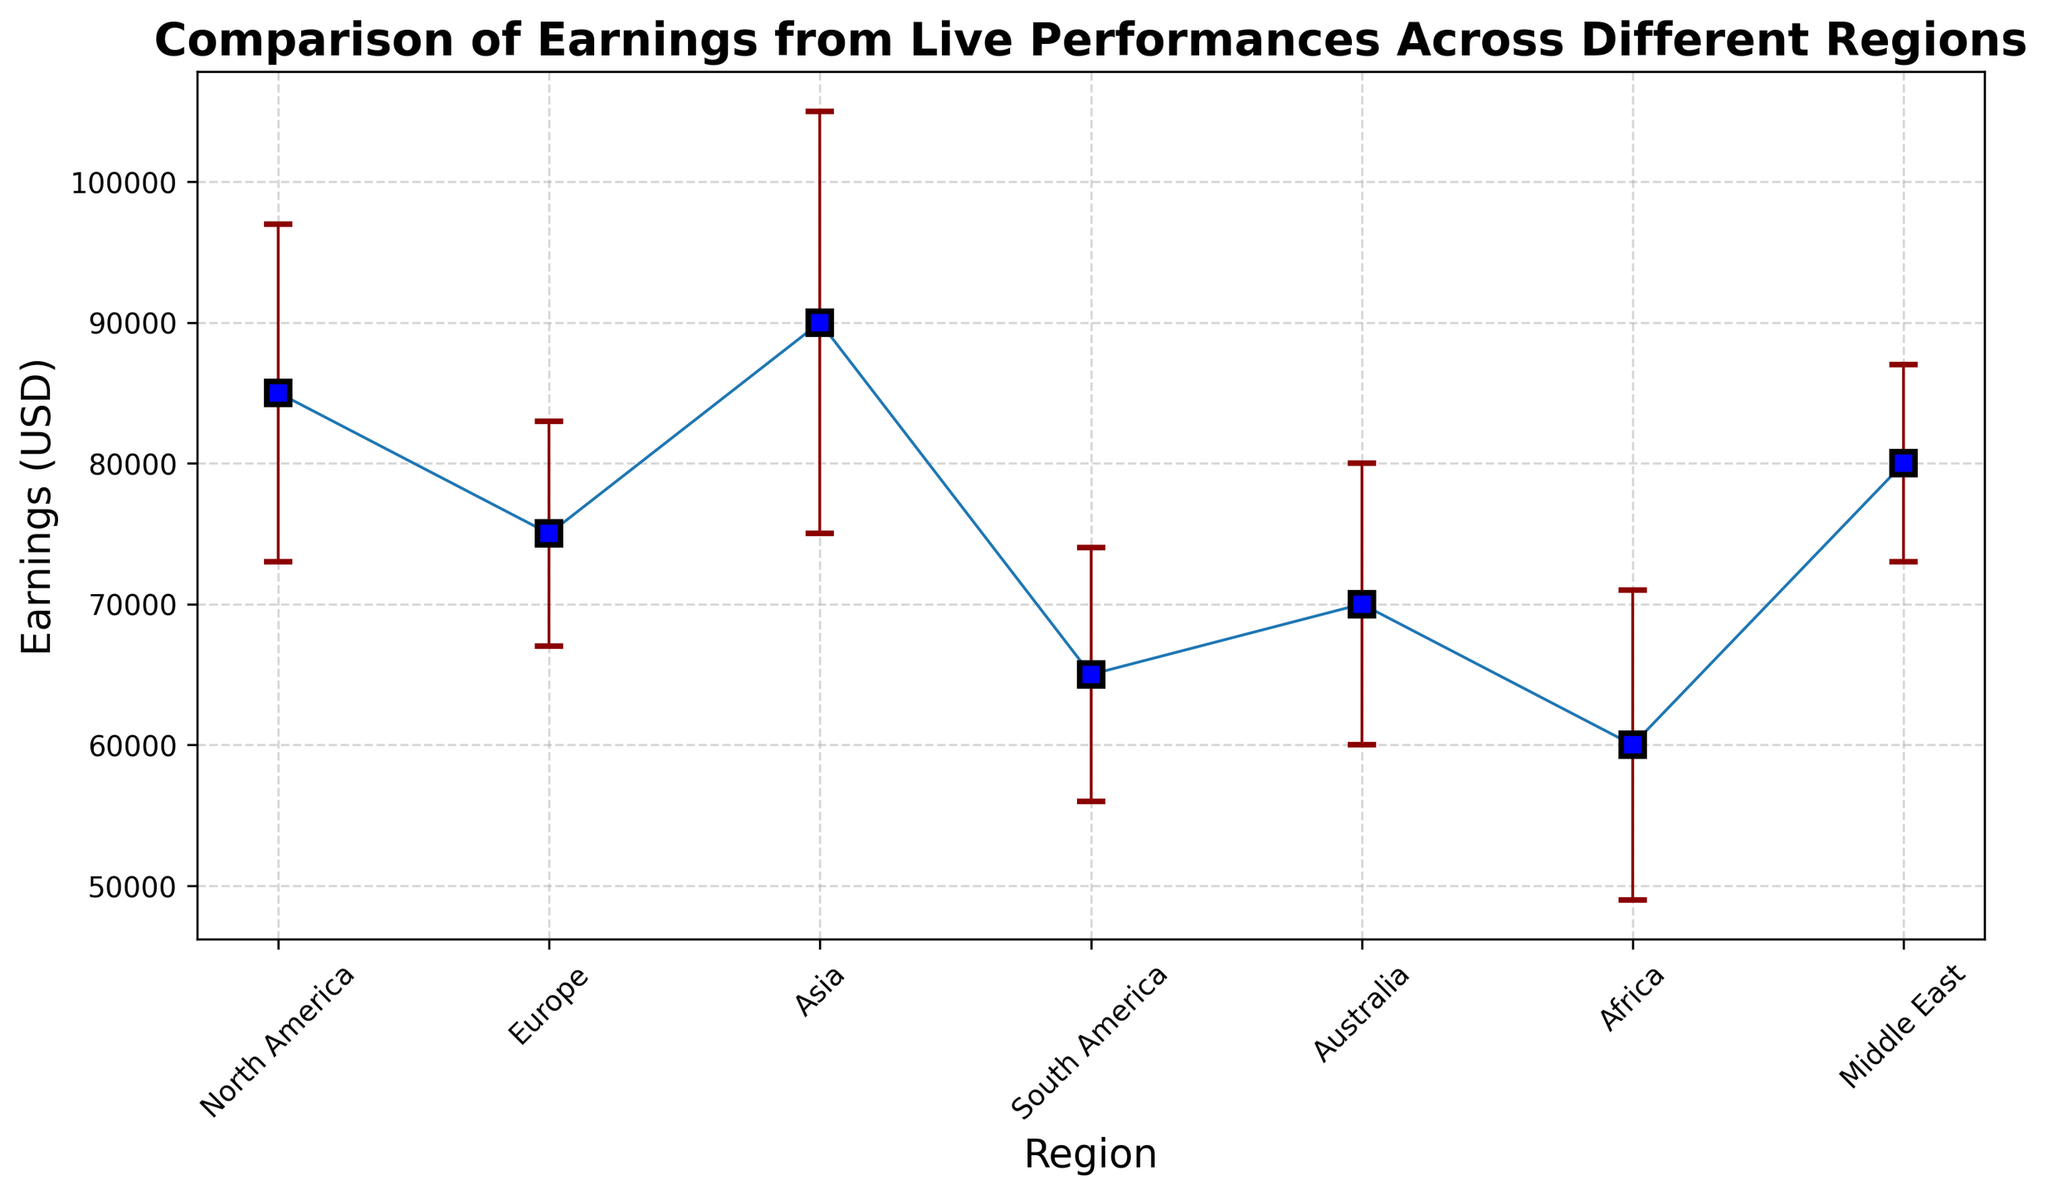What region has the highest earnings from live performances? The region with the highest earnings can be identified by looking at the highest point on the plot. In this case, the highest earnings are in Asia.
Answer: Asia Which region has the lowest earnings from live performances? The region with the lowest earnings can be identified by looking at the lowest point on the plot. In this case, the lowest earnings are in Africa.
Answer: Africa What is the difference in earnings between North America and South America? To find the difference in earnings, subtract the earnings of South America from the earnings of North America: 85000 - 65000 = 20000.
Answer: 20000 Which region has the smallest standard deviation in earnings? The smallest standard deviation is indicated by the shortest error bar on the plot. In this case, the Middle East has the shortest error bar, indicating the smallest standard deviation.
Answer: Middle East What are the earnings for Europe and are they greater than or less than Africa? The earnings for Europe can be read directly from the plot. Europe earnings are 75000, while Africa earnings are 60000. Since 75000 is greater than 60000, Europe earnings are greater than Africa's.
Answer: Europe earnings are 75000 and they are greater than Africa's earnings What is the sum of earnings for North America and Asia? Sum up the earnings of North America and Asia: 85000 + 90000 = 175000.
Answer: 175000 Which region has the highest level of uncertainty in its earnings? The highest level of uncertainty is indicated by the region with the longest error bar. In this case, Asia has the longest error bar, indicating the highest standard deviation.
Answer: Asia How does the earnings of the Middle East compare to Australia? The earnings of the Middle East are 80000 while the earnings of Australia are 70000. Since 80000 is greater than 70000, the Middle East has higher earnings.
Answer: Middle East earnings are higher than Australia What is the average earnings for the regions North America, Europe, and Asia? To find the average, sum the earnings of North America, Europe, and Asia, and then divide by the number of regions: (85000 + 75000 + 90000) / 3 = 166666.67.
Answer: 166666.67 Which region has earnings closest to the overall median earnings of all regions? To find the median earnings, sort the earnings: 60000, 65000, 70000, 75000, 80000, 85000, 90000. The middle value in this sorted list is 75000. Therefore, Europe, which has earnings of 75000, has earnings closest to the median.
Answer: Europe 